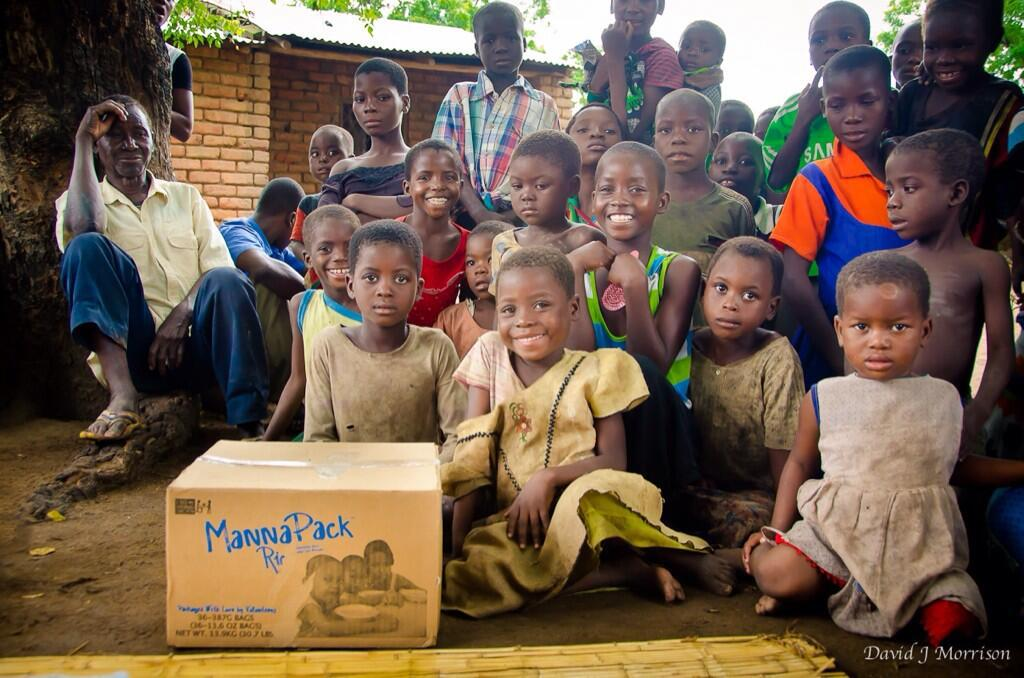What is the main object in the middle of the image? There is a box in the middle of the image. What are the people doing in relation to the box? The people are sitting and standing behind the box. What is the facial expression of the people in the image? The people are smiling. What can be seen in the background of the image? There are trees and a house visible in the background. How many brothers are standing next to the box in the image? There is no mention of brothers in the image, and no specific individuals are identified. 